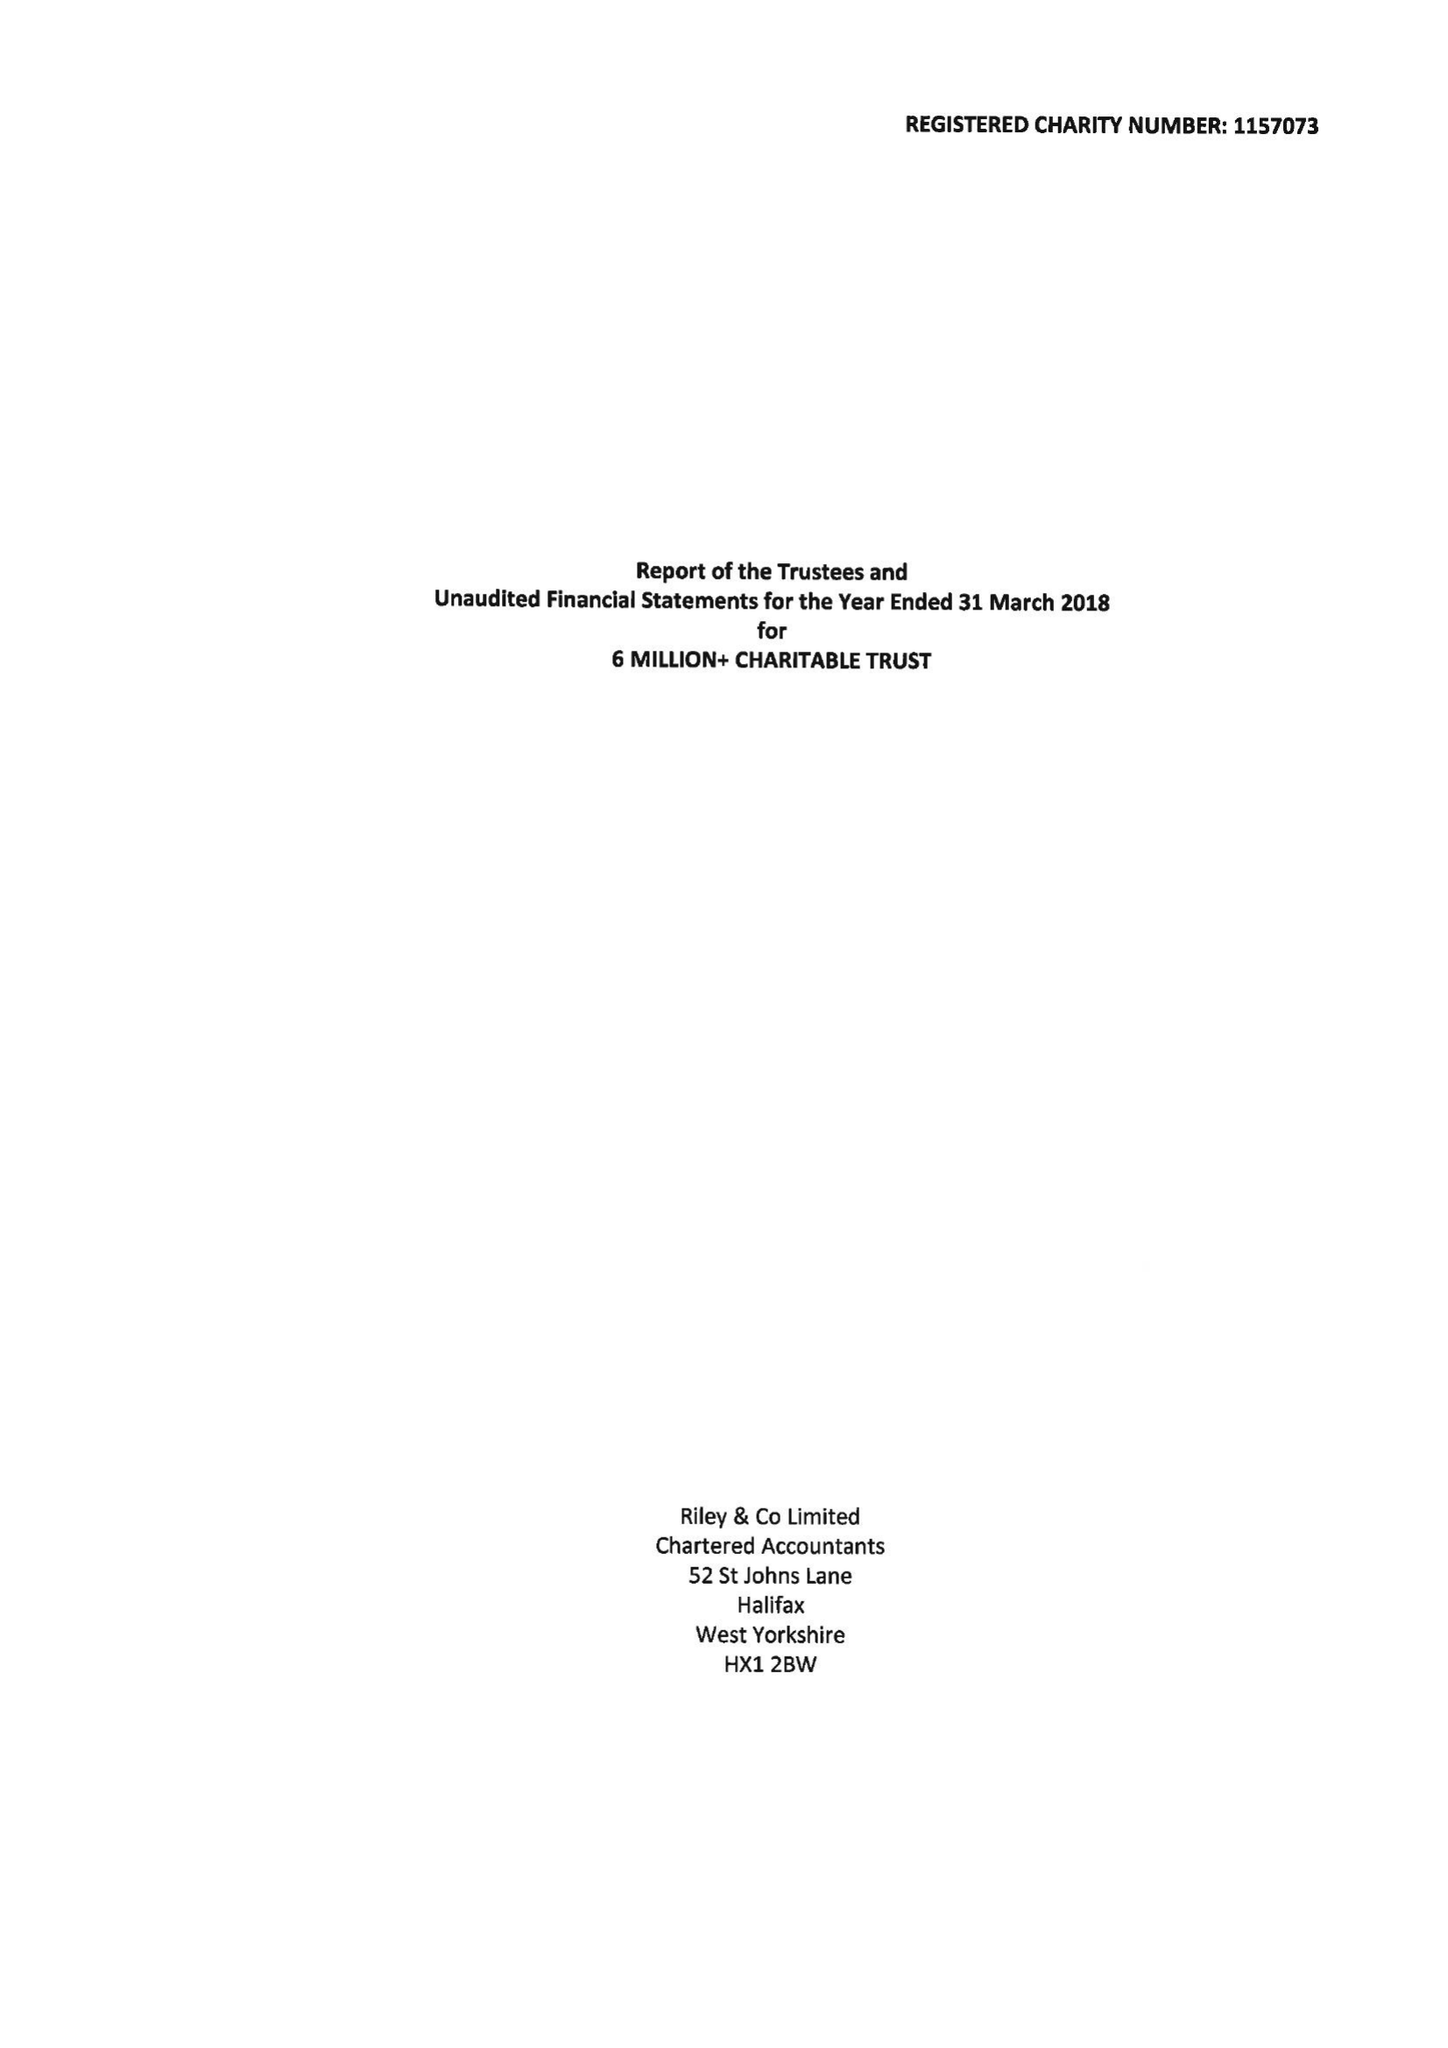What is the value for the charity_name?
Answer the question using a single word or phrase. 6 Million+ Charitable Trust 